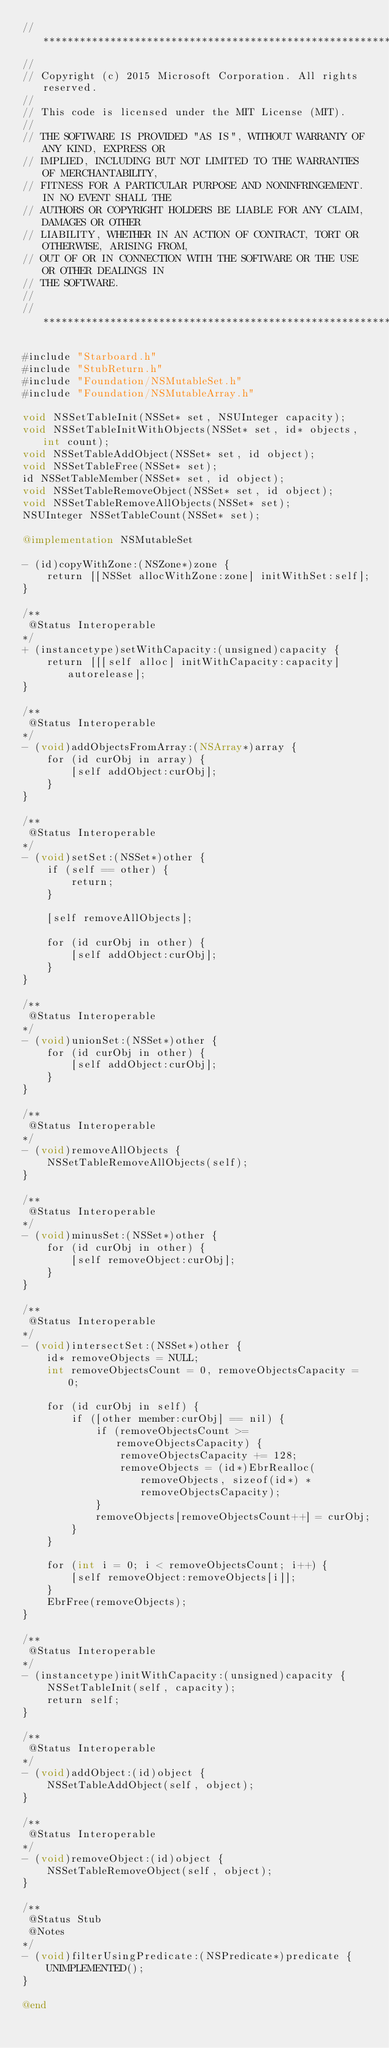Convert code to text. <code><loc_0><loc_0><loc_500><loc_500><_ObjectiveC_>//******************************************************************************
//
// Copyright (c) 2015 Microsoft Corporation. All rights reserved.
//
// This code is licensed under the MIT License (MIT).
//
// THE SOFTWARE IS PROVIDED "AS IS", WITHOUT WARRANTY OF ANY KIND, EXPRESS OR
// IMPLIED, INCLUDING BUT NOT LIMITED TO THE WARRANTIES OF MERCHANTABILITY,
// FITNESS FOR A PARTICULAR PURPOSE AND NONINFRINGEMENT. IN NO EVENT SHALL THE
// AUTHORS OR COPYRIGHT HOLDERS BE LIABLE FOR ANY CLAIM, DAMAGES OR OTHER
// LIABILITY, WHETHER IN AN ACTION OF CONTRACT, TORT OR OTHERWISE, ARISING FROM,
// OUT OF OR IN CONNECTION WITH THE SOFTWARE OR THE USE OR OTHER DEALINGS IN
// THE SOFTWARE.
//
//******************************************************************************

#include "Starboard.h"
#include "StubReturn.h"
#include "Foundation/NSMutableSet.h"
#include "Foundation/NSMutableArray.h"

void NSSetTableInit(NSSet* set, NSUInteger capacity);
void NSSetTableInitWithObjects(NSSet* set, id* objects, int count);
void NSSetTableAddObject(NSSet* set, id object);
void NSSetTableFree(NSSet* set);
id NSSetTableMember(NSSet* set, id object);
void NSSetTableRemoveObject(NSSet* set, id object);
void NSSetTableRemoveAllObjects(NSSet* set);
NSUInteger NSSetTableCount(NSSet* set);

@implementation NSMutableSet

- (id)copyWithZone:(NSZone*)zone {
    return [[NSSet allocWithZone:zone] initWithSet:self];
}

/**
 @Status Interoperable
*/
+ (instancetype)setWithCapacity:(unsigned)capacity {
    return [[[self alloc] initWithCapacity:capacity] autorelease];
}

/**
 @Status Interoperable
*/
- (void)addObjectsFromArray:(NSArray*)array {
    for (id curObj in array) {
        [self addObject:curObj];
    }
}

/**
 @Status Interoperable
*/
- (void)setSet:(NSSet*)other {
    if (self == other) {
        return;
    }

    [self removeAllObjects];

    for (id curObj in other) {
        [self addObject:curObj];
    }
}

/**
 @Status Interoperable
*/
- (void)unionSet:(NSSet*)other {
    for (id curObj in other) {
        [self addObject:curObj];
    }
}

/**
 @Status Interoperable
*/
- (void)removeAllObjects {
    NSSetTableRemoveAllObjects(self);
}

/**
 @Status Interoperable
*/
- (void)minusSet:(NSSet*)other {
    for (id curObj in other) {
        [self removeObject:curObj];
    }
}

/**
 @Status Interoperable
*/
- (void)intersectSet:(NSSet*)other {
    id* removeObjects = NULL;
    int removeObjectsCount = 0, removeObjectsCapacity = 0;

    for (id curObj in self) {
        if ([other member:curObj] == nil) {
            if (removeObjectsCount >= removeObjectsCapacity) {
                removeObjectsCapacity += 128;
                removeObjects = (id*)EbrRealloc(removeObjects, sizeof(id*) * removeObjectsCapacity);
            }
            removeObjects[removeObjectsCount++] = curObj;
        }
    }

    for (int i = 0; i < removeObjectsCount; i++) {
        [self removeObject:removeObjects[i]];
    }
    EbrFree(removeObjects);
}

/**
 @Status Interoperable
*/
- (instancetype)initWithCapacity:(unsigned)capacity {
    NSSetTableInit(self, capacity);
    return self;
}

/**
 @Status Interoperable
*/
- (void)addObject:(id)object {
    NSSetTableAddObject(self, object);
}

/**
 @Status Interoperable
*/
- (void)removeObject:(id)object {
    NSSetTableRemoveObject(self, object);
}

/**
 @Status Stub
 @Notes
*/
- (void)filterUsingPredicate:(NSPredicate*)predicate {
    UNIMPLEMENTED();
}

@end
</code> 